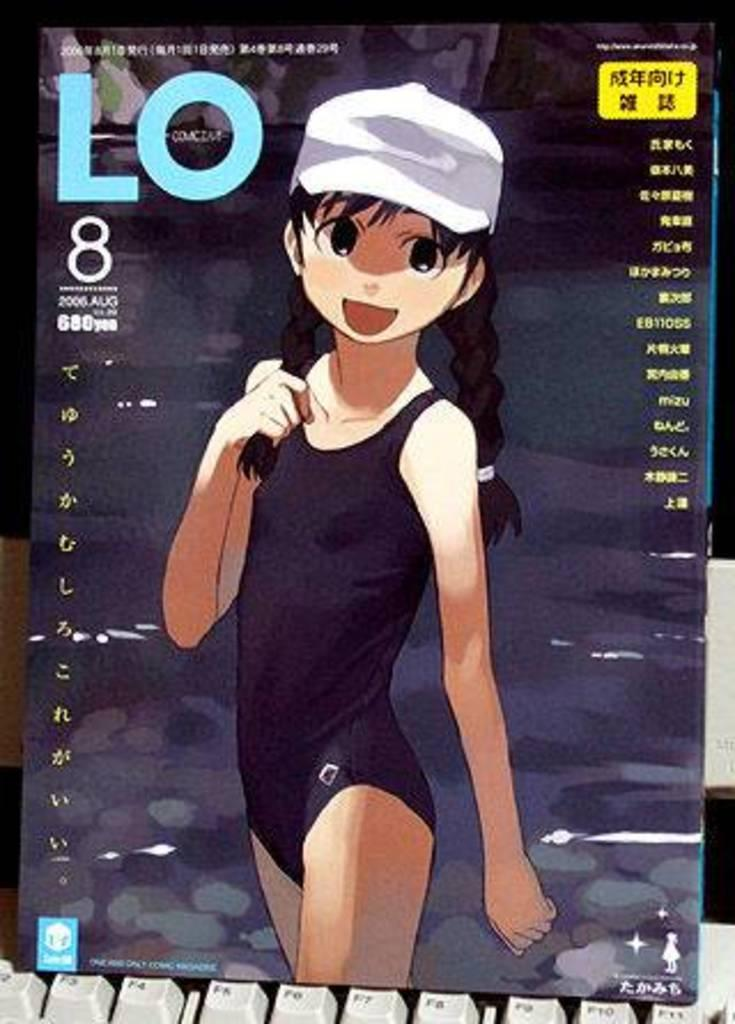What is the main object in the image? There is a book in the image. What can be seen on the cover page of the book? The cover page of the book has an animation of a girl and some text. What other object is visible in the image? There is a keyboard in the image. Where is the servant standing in the image? There is no servant present in the image. What type of cabbage is being used as a prop in the image? There is no cabbage present in the image. 